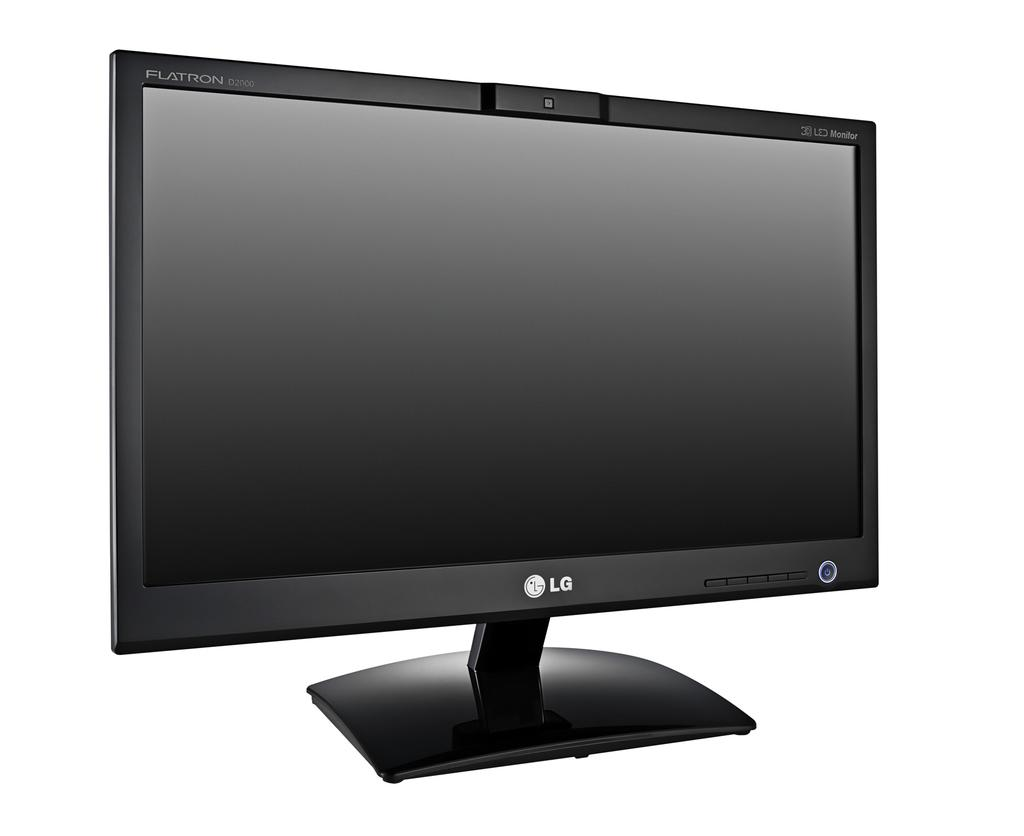<image>
Present a compact description of the photo's key features. A black LG monitor with middle stand and center camera 